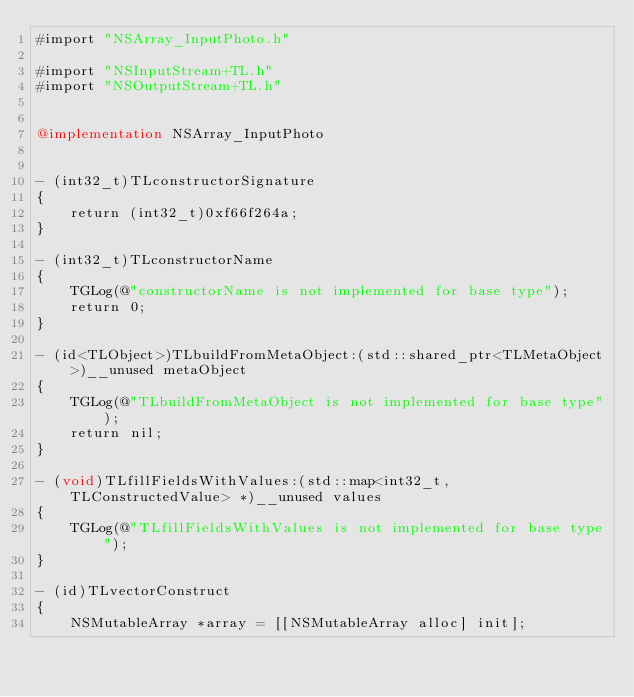Convert code to text. <code><loc_0><loc_0><loc_500><loc_500><_ObjectiveC_>#import "NSArray_InputPhoto.h"

#import "NSInputStream+TL.h"
#import "NSOutputStream+TL.h"


@implementation NSArray_InputPhoto


- (int32_t)TLconstructorSignature
{
    return (int32_t)0xf66f264a;
}

- (int32_t)TLconstructorName
{
    TGLog(@"constructorName is not implemented for base type");
    return 0;
}

- (id<TLObject>)TLbuildFromMetaObject:(std::shared_ptr<TLMetaObject>)__unused metaObject
{
    TGLog(@"TLbuildFromMetaObject is not implemented for base type");
    return nil;
}

- (void)TLfillFieldsWithValues:(std::map<int32_t, TLConstructedValue> *)__unused values
{
    TGLog(@"TLfillFieldsWithValues is not implemented for base type");
}

- (id)TLvectorConstruct
{
    NSMutableArray *array = [[NSMutableArray alloc] init];</code> 